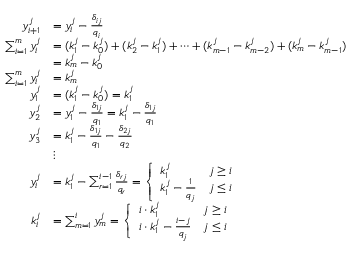<formula> <loc_0><loc_0><loc_500><loc_500>{ \begin{array} { r l } { y _ { i + 1 } ^ { j } } & { = y _ { i } ^ { j } - { \frac { \delta _ { i j } } { q _ { i } } } } \\ { \sum _ { i = 1 } ^ { m } y _ { i } ^ { j } } & { = ( k _ { 1 } ^ { j } - k _ { 0 } ^ { j } ) + ( k _ { 2 } ^ { j } - k _ { 1 } ^ { j } ) + \cdots + ( k _ { m - 1 } ^ { j } - k _ { m - 2 } ^ { j } ) + ( k _ { m } ^ { j } - k _ { m - 1 } ^ { j } ) } \\ & { = k _ { m } ^ { j } - k _ { 0 } ^ { j } } \\ { \sum _ { i = 1 } ^ { m } y _ { i } ^ { j } } & { = k _ { m } ^ { j } } \\ { y _ { 1 } ^ { j } } & { = ( k _ { 1 } ^ { j } - k _ { 0 } ^ { j } ) = k _ { 1 } ^ { j } } \\ { y _ { 2 } ^ { j } } & { = y _ { 1 } ^ { j } - { \frac { \delta _ { 1 j } } { q _ { 1 } } } = k _ { 1 } ^ { j } - { \frac { \delta _ { 1 j } } { q _ { 1 } } } } \\ { y _ { 3 } ^ { j } } & { = k _ { 1 } ^ { j } - { \frac { \delta _ { 1 j } } { q _ { 1 } } } - { \frac { \delta _ { 2 j } } { q _ { 2 } } } } \\ & { \vdots } \\ { y _ { i } ^ { j } } & { = k _ { 1 } ^ { j } - \sum _ { r = 1 } ^ { i - 1 } { \frac { \delta _ { r j } } { q _ { r } } } = { \left \{ \begin{array} { l l } { k _ { 1 } ^ { j } } & { j \geq i } \\ { k _ { 1 } ^ { j } - { \frac { 1 } { q _ { j } } } } & { j \leq i } \end{array} } } \\ { k _ { i } ^ { j } } & { = \sum _ { m = 1 } ^ { i } y _ { m } ^ { j } = { \left \{ \begin{array} { l l } { i \cdot k _ { 1 } ^ { j } } & { j \geq i } \\ { i \cdot k _ { 1 } ^ { j } - { \frac { i - j } { q _ { j } } } } & { j \leq i } \end{array} } } \end{array} }</formula> 